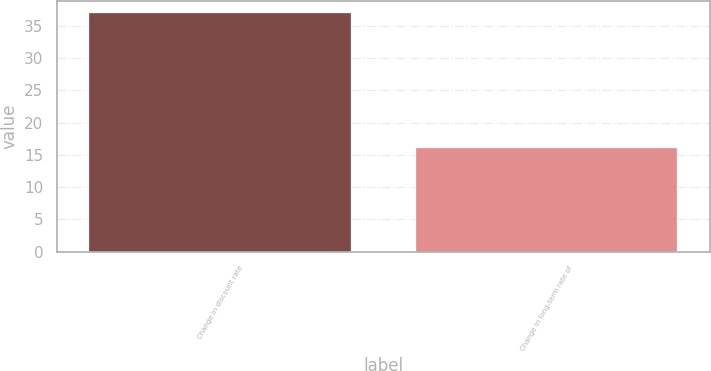Convert chart to OTSL. <chart><loc_0><loc_0><loc_500><loc_500><bar_chart><fcel>Change in discount rate<fcel>Change in long-term rate of<nl><fcel>37<fcel>16<nl></chart> 